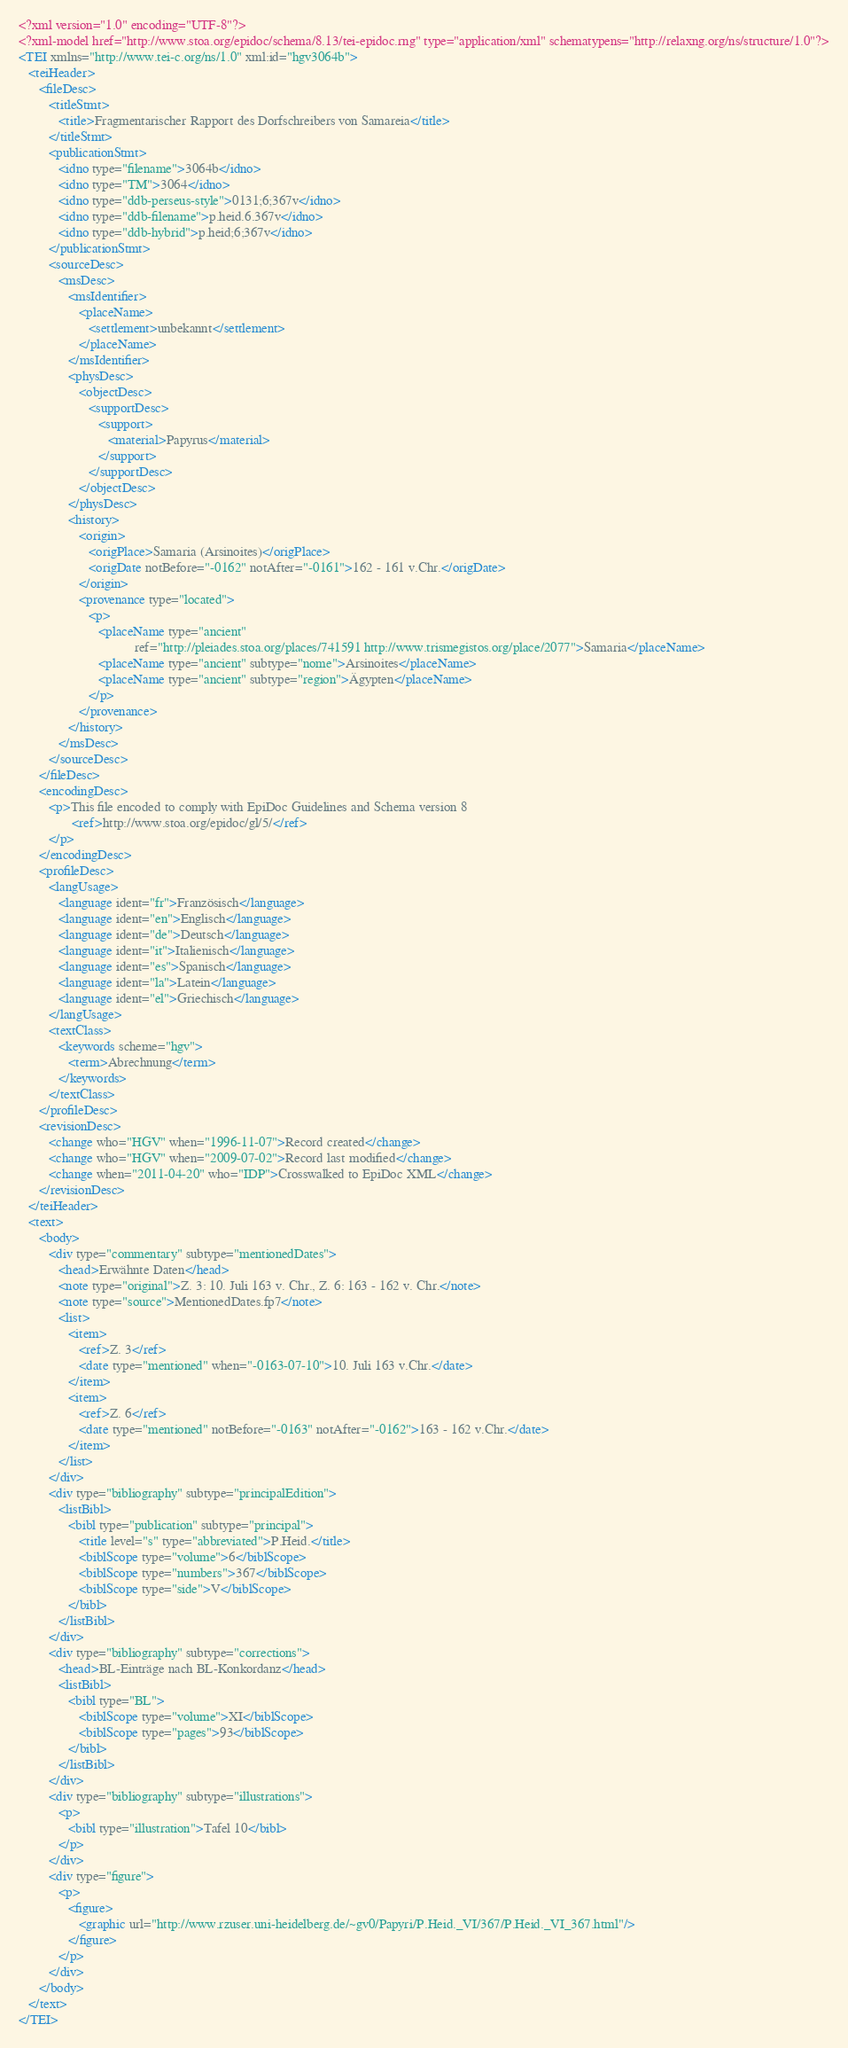<code> <loc_0><loc_0><loc_500><loc_500><_XML_><?xml version="1.0" encoding="UTF-8"?>
<?xml-model href="http://www.stoa.org/epidoc/schema/8.13/tei-epidoc.rng" type="application/xml" schematypens="http://relaxng.org/ns/structure/1.0"?>
<TEI xmlns="http://www.tei-c.org/ns/1.0" xml:id="hgv3064b">
   <teiHeader>
      <fileDesc>
         <titleStmt>
            <title>Fragmentarischer Rapport des Dorfschreibers von Samareia</title>
         </titleStmt>
         <publicationStmt>
            <idno type="filename">3064b</idno>
            <idno type="TM">3064</idno>
            <idno type="ddb-perseus-style">0131;6;367v</idno>
            <idno type="ddb-filename">p.heid.6.367v</idno>
            <idno type="ddb-hybrid">p.heid;6;367v</idno>
         </publicationStmt>
         <sourceDesc>
            <msDesc>
               <msIdentifier>
                  <placeName>
                     <settlement>unbekannt</settlement>
                  </placeName>
               </msIdentifier>
               <physDesc>
                  <objectDesc>
                     <supportDesc>
                        <support>
                           <material>Papyrus</material>
                        </support>
                     </supportDesc>
                  </objectDesc>
               </physDesc>
               <history>
                  <origin>
                     <origPlace>Samaria (Arsinoites)</origPlace>
                     <origDate notBefore="-0162" notAfter="-0161">162 - 161 v.Chr.</origDate>
                  </origin>
                  <provenance type="located">
                     <p>
                        <placeName type="ancient"
                                   ref="http://pleiades.stoa.org/places/741591 http://www.trismegistos.org/place/2077">Samaria</placeName>
                        <placeName type="ancient" subtype="nome">Arsinoites</placeName>
                        <placeName type="ancient" subtype="region">Ägypten</placeName>
                     </p>
                  </provenance>
               </history>
            </msDesc>
         </sourceDesc>
      </fileDesc>
      <encodingDesc>
         <p>This file encoded to comply with EpiDoc Guidelines and Schema version 8
                <ref>http://www.stoa.org/epidoc/gl/5/</ref>
         </p>
      </encodingDesc>
      <profileDesc>
         <langUsage>
            <language ident="fr">Französisch</language>
            <language ident="en">Englisch</language>
            <language ident="de">Deutsch</language>
            <language ident="it">Italienisch</language>
            <language ident="es">Spanisch</language>
            <language ident="la">Latein</language>
            <language ident="el">Griechisch</language>
         </langUsage>
         <textClass>
            <keywords scheme="hgv">
               <term>Abrechnung</term>
            </keywords>
         </textClass>
      </profileDesc>
      <revisionDesc>
         <change who="HGV" when="1996-11-07">Record created</change>
         <change who="HGV" when="2009-07-02">Record last modified</change>
         <change when="2011-04-20" who="IDP">Crosswalked to EpiDoc XML</change>
      </revisionDesc>
   </teiHeader>
   <text>
      <body>
         <div type="commentary" subtype="mentionedDates">
            <head>Erwähnte Daten</head>
            <note type="original">Z. 3: 10. Juli 163 v. Chr., Z. 6: 163 - 162 v. Chr.</note>
            <note type="source">MentionedDates.fp7</note>
            <list>
               <item>
                  <ref>Z. 3</ref>
                  <date type="mentioned" when="-0163-07-10">10. Juli 163 v.Chr.</date>
               </item>
               <item>
                  <ref>Z. 6</ref>
                  <date type="mentioned" notBefore="-0163" notAfter="-0162">163 - 162 v.Chr.</date>
               </item>
            </list>
         </div>
         <div type="bibliography" subtype="principalEdition">
            <listBibl>
               <bibl type="publication" subtype="principal">
                  <title level="s" type="abbreviated">P.Heid.</title>
                  <biblScope type="volume">6</biblScope>
                  <biblScope type="numbers">367</biblScope>
                  <biblScope type="side">V</biblScope>
               </bibl>
            </listBibl>
         </div>
         <div type="bibliography" subtype="corrections">
            <head>BL-Einträge nach BL-Konkordanz</head>
            <listBibl>
               <bibl type="BL">
                  <biblScope type="volume">XI</biblScope>
                  <biblScope type="pages">93</biblScope>
               </bibl>
            </listBibl>
         </div>
         <div type="bibliography" subtype="illustrations">
            <p>
               <bibl type="illustration">Tafel 10</bibl>
            </p>
         </div>
         <div type="figure">
            <p>
               <figure>
                  <graphic url="http://www.rzuser.uni-heidelberg.de/~gv0/Papyri/P.Heid._VI/367/P.Heid._VI_367.html"/>
               </figure>
            </p>
         </div>
      </body>
   </text>
</TEI>
</code> 